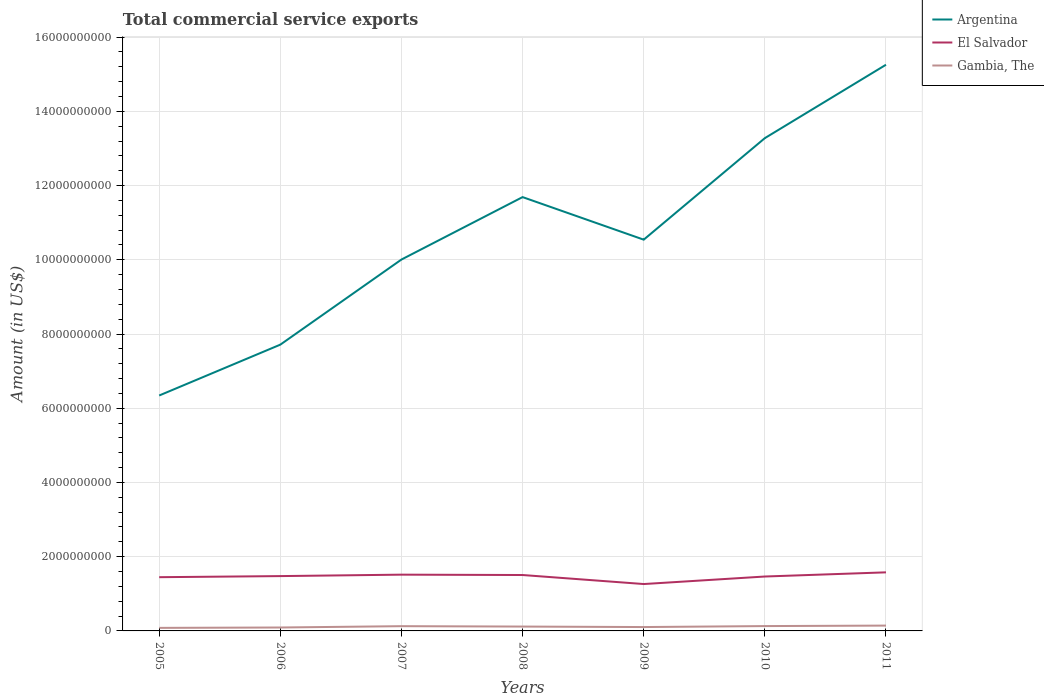Is the number of lines equal to the number of legend labels?
Provide a succinct answer. Yes. Across all years, what is the maximum total commercial service exports in Gambia, The?
Your response must be concise. 8.22e+07. In which year was the total commercial service exports in Argentina maximum?
Offer a very short reply. 2005. What is the total total commercial service exports in El Salvador in the graph?
Your answer should be very brief. 9.69e+06. What is the difference between the highest and the second highest total commercial service exports in Argentina?
Ensure brevity in your answer.  8.91e+09. What is the difference between the highest and the lowest total commercial service exports in El Salvador?
Keep it short and to the point. 5. How many lines are there?
Make the answer very short. 3. What is the difference between two consecutive major ticks on the Y-axis?
Your response must be concise. 2.00e+09. Are the values on the major ticks of Y-axis written in scientific E-notation?
Your answer should be very brief. No. Does the graph contain any zero values?
Ensure brevity in your answer.  No. Does the graph contain grids?
Provide a succinct answer. Yes. Where does the legend appear in the graph?
Your response must be concise. Top right. How many legend labels are there?
Your answer should be very brief. 3. How are the legend labels stacked?
Keep it short and to the point. Vertical. What is the title of the graph?
Provide a short and direct response. Total commercial service exports. What is the label or title of the Y-axis?
Your answer should be very brief. Amount (in US$). What is the Amount (in US$) of Argentina in 2005?
Provide a short and direct response. 6.34e+09. What is the Amount (in US$) of El Salvador in 2005?
Keep it short and to the point. 1.45e+09. What is the Amount (in US$) of Gambia, The in 2005?
Provide a succinct answer. 8.22e+07. What is the Amount (in US$) of Argentina in 2006?
Your answer should be very brief. 7.71e+09. What is the Amount (in US$) in El Salvador in 2006?
Your answer should be very brief. 1.48e+09. What is the Amount (in US$) in Gambia, The in 2006?
Give a very brief answer. 9.21e+07. What is the Amount (in US$) of Argentina in 2007?
Keep it short and to the point. 1.00e+1. What is the Amount (in US$) of El Salvador in 2007?
Your answer should be compact. 1.52e+09. What is the Amount (in US$) of Gambia, The in 2007?
Ensure brevity in your answer.  1.28e+08. What is the Amount (in US$) in Argentina in 2008?
Provide a succinct answer. 1.17e+1. What is the Amount (in US$) of El Salvador in 2008?
Ensure brevity in your answer.  1.51e+09. What is the Amount (in US$) of Gambia, The in 2008?
Your answer should be compact. 1.18e+08. What is the Amount (in US$) of Argentina in 2009?
Ensure brevity in your answer.  1.05e+1. What is the Amount (in US$) in El Salvador in 2009?
Ensure brevity in your answer.  1.26e+09. What is the Amount (in US$) of Gambia, The in 2009?
Your answer should be very brief. 1.04e+08. What is the Amount (in US$) in Argentina in 2010?
Your answer should be compact. 1.33e+1. What is the Amount (in US$) of El Salvador in 2010?
Your answer should be very brief. 1.47e+09. What is the Amount (in US$) in Gambia, The in 2010?
Your answer should be very brief. 1.31e+08. What is the Amount (in US$) of Argentina in 2011?
Give a very brief answer. 1.53e+1. What is the Amount (in US$) of El Salvador in 2011?
Give a very brief answer. 1.58e+09. What is the Amount (in US$) of Gambia, The in 2011?
Give a very brief answer. 1.44e+08. Across all years, what is the maximum Amount (in US$) of Argentina?
Your answer should be compact. 1.53e+1. Across all years, what is the maximum Amount (in US$) of El Salvador?
Make the answer very short. 1.58e+09. Across all years, what is the maximum Amount (in US$) in Gambia, The?
Your answer should be compact. 1.44e+08. Across all years, what is the minimum Amount (in US$) of Argentina?
Offer a very short reply. 6.34e+09. Across all years, what is the minimum Amount (in US$) of El Salvador?
Keep it short and to the point. 1.26e+09. Across all years, what is the minimum Amount (in US$) of Gambia, The?
Offer a very short reply. 8.22e+07. What is the total Amount (in US$) of Argentina in the graph?
Your response must be concise. 7.48e+1. What is the total Amount (in US$) of El Salvador in the graph?
Ensure brevity in your answer.  1.03e+1. What is the total Amount (in US$) in Gambia, The in the graph?
Your response must be concise. 7.98e+08. What is the difference between the Amount (in US$) in Argentina in 2005 and that in 2006?
Keep it short and to the point. -1.37e+09. What is the difference between the Amount (in US$) of El Salvador in 2005 and that in 2006?
Offer a terse response. -2.94e+07. What is the difference between the Amount (in US$) in Gambia, The in 2005 and that in 2006?
Make the answer very short. -9.87e+06. What is the difference between the Amount (in US$) of Argentina in 2005 and that in 2007?
Your answer should be very brief. -3.66e+09. What is the difference between the Amount (in US$) in El Salvador in 2005 and that in 2007?
Your answer should be very brief. -6.83e+07. What is the difference between the Amount (in US$) in Gambia, The in 2005 and that in 2007?
Give a very brief answer. -4.57e+07. What is the difference between the Amount (in US$) in Argentina in 2005 and that in 2008?
Your answer should be compact. -5.35e+09. What is the difference between the Amount (in US$) in El Salvador in 2005 and that in 2008?
Your response must be concise. -5.86e+07. What is the difference between the Amount (in US$) in Gambia, The in 2005 and that in 2008?
Offer a terse response. -3.54e+07. What is the difference between the Amount (in US$) of Argentina in 2005 and that in 2009?
Keep it short and to the point. -4.20e+09. What is the difference between the Amount (in US$) of El Salvador in 2005 and that in 2009?
Provide a short and direct response. 1.85e+08. What is the difference between the Amount (in US$) of Gambia, The in 2005 and that in 2009?
Your answer should be compact. -2.20e+07. What is the difference between the Amount (in US$) in Argentina in 2005 and that in 2010?
Your answer should be very brief. -6.93e+09. What is the difference between the Amount (in US$) of El Salvador in 2005 and that in 2010?
Provide a short and direct response. -1.80e+07. What is the difference between the Amount (in US$) in Gambia, The in 2005 and that in 2010?
Your answer should be compact. -4.84e+07. What is the difference between the Amount (in US$) of Argentina in 2005 and that in 2011?
Provide a short and direct response. -8.91e+09. What is the difference between the Amount (in US$) of El Salvador in 2005 and that in 2011?
Your answer should be very brief. -1.31e+08. What is the difference between the Amount (in US$) of Gambia, The in 2005 and that in 2011?
Keep it short and to the point. -6.15e+07. What is the difference between the Amount (in US$) in Argentina in 2006 and that in 2007?
Keep it short and to the point. -2.29e+09. What is the difference between the Amount (in US$) in El Salvador in 2006 and that in 2007?
Your answer should be very brief. -3.89e+07. What is the difference between the Amount (in US$) in Gambia, The in 2006 and that in 2007?
Ensure brevity in your answer.  -3.59e+07. What is the difference between the Amount (in US$) in Argentina in 2006 and that in 2008?
Provide a short and direct response. -3.98e+09. What is the difference between the Amount (in US$) in El Salvador in 2006 and that in 2008?
Your response must be concise. -2.92e+07. What is the difference between the Amount (in US$) in Gambia, The in 2006 and that in 2008?
Your answer should be compact. -2.55e+07. What is the difference between the Amount (in US$) of Argentina in 2006 and that in 2009?
Offer a terse response. -2.83e+09. What is the difference between the Amount (in US$) of El Salvador in 2006 and that in 2009?
Give a very brief answer. 2.14e+08. What is the difference between the Amount (in US$) of Gambia, The in 2006 and that in 2009?
Provide a short and direct response. -1.21e+07. What is the difference between the Amount (in US$) of Argentina in 2006 and that in 2010?
Make the answer very short. -5.56e+09. What is the difference between the Amount (in US$) in El Salvador in 2006 and that in 2010?
Provide a short and direct response. 1.14e+07. What is the difference between the Amount (in US$) of Gambia, The in 2006 and that in 2010?
Provide a succinct answer. -3.86e+07. What is the difference between the Amount (in US$) of Argentina in 2006 and that in 2011?
Your response must be concise. -7.54e+09. What is the difference between the Amount (in US$) in El Salvador in 2006 and that in 2011?
Provide a succinct answer. -1.01e+08. What is the difference between the Amount (in US$) in Gambia, The in 2006 and that in 2011?
Offer a very short reply. -5.16e+07. What is the difference between the Amount (in US$) in Argentina in 2007 and that in 2008?
Your answer should be compact. -1.68e+09. What is the difference between the Amount (in US$) in El Salvador in 2007 and that in 2008?
Provide a short and direct response. 9.69e+06. What is the difference between the Amount (in US$) in Gambia, The in 2007 and that in 2008?
Offer a very short reply. 1.04e+07. What is the difference between the Amount (in US$) in Argentina in 2007 and that in 2009?
Your response must be concise. -5.35e+08. What is the difference between the Amount (in US$) of El Salvador in 2007 and that in 2009?
Offer a terse response. 2.53e+08. What is the difference between the Amount (in US$) in Gambia, The in 2007 and that in 2009?
Make the answer very short. 2.38e+07. What is the difference between the Amount (in US$) in Argentina in 2007 and that in 2010?
Give a very brief answer. -3.27e+09. What is the difference between the Amount (in US$) in El Salvador in 2007 and that in 2010?
Give a very brief answer. 5.03e+07. What is the difference between the Amount (in US$) in Gambia, The in 2007 and that in 2010?
Your answer should be very brief. -2.70e+06. What is the difference between the Amount (in US$) in Argentina in 2007 and that in 2011?
Your answer should be very brief. -5.25e+09. What is the difference between the Amount (in US$) of El Salvador in 2007 and that in 2011?
Ensure brevity in your answer.  -6.23e+07. What is the difference between the Amount (in US$) of Gambia, The in 2007 and that in 2011?
Provide a succinct answer. -1.58e+07. What is the difference between the Amount (in US$) of Argentina in 2008 and that in 2009?
Your answer should be compact. 1.15e+09. What is the difference between the Amount (in US$) of El Salvador in 2008 and that in 2009?
Offer a terse response. 2.43e+08. What is the difference between the Amount (in US$) of Gambia, The in 2008 and that in 2009?
Your response must be concise. 1.34e+07. What is the difference between the Amount (in US$) in Argentina in 2008 and that in 2010?
Offer a terse response. -1.59e+09. What is the difference between the Amount (in US$) of El Salvador in 2008 and that in 2010?
Keep it short and to the point. 4.06e+07. What is the difference between the Amount (in US$) of Gambia, The in 2008 and that in 2010?
Keep it short and to the point. -1.31e+07. What is the difference between the Amount (in US$) in Argentina in 2008 and that in 2011?
Your response must be concise. -3.57e+09. What is the difference between the Amount (in US$) of El Salvador in 2008 and that in 2011?
Offer a terse response. -7.20e+07. What is the difference between the Amount (in US$) of Gambia, The in 2008 and that in 2011?
Make the answer very short. -2.62e+07. What is the difference between the Amount (in US$) in Argentina in 2009 and that in 2010?
Offer a very short reply. -2.74e+09. What is the difference between the Amount (in US$) in El Salvador in 2009 and that in 2010?
Provide a succinct answer. -2.03e+08. What is the difference between the Amount (in US$) in Gambia, The in 2009 and that in 2010?
Provide a short and direct response. -2.65e+07. What is the difference between the Amount (in US$) in Argentina in 2009 and that in 2011?
Provide a short and direct response. -4.71e+09. What is the difference between the Amount (in US$) in El Salvador in 2009 and that in 2011?
Your answer should be very brief. -3.15e+08. What is the difference between the Amount (in US$) of Gambia, The in 2009 and that in 2011?
Keep it short and to the point. -3.95e+07. What is the difference between the Amount (in US$) in Argentina in 2010 and that in 2011?
Give a very brief answer. -1.98e+09. What is the difference between the Amount (in US$) of El Salvador in 2010 and that in 2011?
Offer a very short reply. -1.13e+08. What is the difference between the Amount (in US$) of Gambia, The in 2010 and that in 2011?
Provide a succinct answer. -1.31e+07. What is the difference between the Amount (in US$) in Argentina in 2005 and the Amount (in US$) in El Salvador in 2006?
Make the answer very short. 4.87e+09. What is the difference between the Amount (in US$) in Argentina in 2005 and the Amount (in US$) in Gambia, The in 2006?
Offer a terse response. 6.25e+09. What is the difference between the Amount (in US$) in El Salvador in 2005 and the Amount (in US$) in Gambia, The in 2006?
Provide a short and direct response. 1.36e+09. What is the difference between the Amount (in US$) of Argentina in 2005 and the Amount (in US$) of El Salvador in 2007?
Ensure brevity in your answer.  4.83e+09. What is the difference between the Amount (in US$) of Argentina in 2005 and the Amount (in US$) of Gambia, The in 2007?
Offer a terse response. 6.21e+09. What is the difference between the Amount (in US$) of El Salvador in 2005 and the Amount (in US$) of Gambia, The in 2007?
Make the answer very short. 1.32e+09. What is the difference between the Amount (in US$) of Argentina in 2005 and the Amount (in US$) of El Salvador in 2008?
Offer a very short reply. 4.84e+09. What is the difference between the Amount (in US$) of Argentina in 2005 and the Amount (in US$) of Gambia, The in 2008?
Your answer should be very brief. 6.23e+09. What is the difference between the Amount (in US$) of El Salvador in 2005 and the Amount (in US$) of Gambia, The in 2008?
Your answer should be very brief. 1.33e+09. What is the difference between the Amount (in US$) in Argentina in 2005 and the Amount (in US$) in El Salvador in 2009?
Give a very brief answer. 5.08e+09. What is the difference between the Amount (in US$) in Argentina in 2005 and the Amount (in US$) in Gambia, The in 2009?
Give a very brief answer. 6.24e+09. What is the difference between the Amount (in US$) in El Salvador in 2005 and the Amount (in US$) in Gambia, The in 2009?
Offer a terse response. 1.34e+09. What is the difference between the Amount (in US$) of Argentina in 2005 and the Amount (in US$) of El Salvador in 2010?
Keep it short and to the point. 4.88e+09. What is the difference between the Amount (in US$) in Argentina in 2005 and the Amount (in US$) in Gambia, The in 2010?
Give a very brief answer. 6.21e+09. What is the difference between the Amount (in US$) of El Salvador in 2005 and the Amount (in US$) of Gambia, The in 2010?
Your response must be concise. 1.32e+09. What is the difference between the Amount (in US$) of Argentina in 2005 and the Amount (in US$) of El Salvador in 2011?
Provide a succinct answer. 4.76e+09. What is the difference between the Amount (in US$) of Argentina in 2005 and the Amount (in US$) of Gambia, The in 2011?
Make the answer very short. 6.20e+09. What is the difference between the Amount (in US$) in El Salvador in 2005 and the Amount (in US$) in Gambia, The in 2011?
Your answer should be compact. 1.30e+09. What is the difference between the Amount (in US$) in Argentina in 2006 and the Amount (in US$) in El Salvador in 2007?
Offer a very short reply. 6.20e+09. What is the difference between the Amount (in US$) of Argentina in 2006 and the Amount (in US$) of Gambia, The in 2007?
Your answer should be compact. 7.59e+09. What is the difference between the Amount (in US$) of El Salvador in 2006 and the Amount (in US$) of Gambia, The in 2007?
Your answer should be very brief. 1.35e+09. What is the difference between the Amount (in US$) of Argentina in 2006 and the Amount (in US$) of El Salvador in 2008?
Provide a short and direct response. 6.21e+09. What is the difference between the Amount (in US$) in Argentina in 2006 and the Amount (in US$) in Gambia, The in 2008?
Provide a succinct answer. 7.60e+09. What is the difference between the Amount (in US$) in El Salvador in 2006 and the Amount (in US$) in Gambia, The in 2008?
Ensure brevity in your answer.  1.36e+09. What is the difference between the Amount (in US$) in Argentina in 2006 and the Amount (in US$) in El Salvador in 2009?
Your answer should be compact. 6.45e+09. What is the difference between the Amount (in US$) of Argentina in 2006 and the Amount (in US$) of Gambia, The in 2009?
Your response must be concise. 7.61e+09. What is the difference between the Amount (in US$) in El Salvador in 2006 and the Amount (in US$) in Gambia, The in 2009?
Keep it short and to the point. 1.37e+09. What is the difference between the Amount (in US$) of Argentina in 2006 and the Amount (in US$) of El Salvador in 2010?
Keep it short and to the point. 6.25e+09. What is the difference between the Amount (in US$) of Argentina in 2006 and the Amount (in US$) of Gambia, The in 2010?
Offer a terse response. 7.58e+09. What is the difference between the Amount (in US$) in El Salvador in 2006 and the Amount (in US$) in Gambia, The in 2010?
Provide a succinct answer. 1.35e+09. What is the difference between the Amount (in US$) in Argentina in 2006 and the Amount (in US$) in El Salvador in 2011?
Your answer should be compact. 6.14e+09. What is the difference between the Amount (in US$) of Argentina in 2006 and the Amount (in US$) of Gambia, The in 2011?
Your answer should be very brief. 7.57e+09. What is the difference between the Amount (in US$) of El Salvador in 2006 and the Amount (in US$) of Gambia, The in 2011?
Your response must be concise. 1.33e+09. What is the difference between the Amount (in US$) of Argentina in 2007 and the Amount (in US$) of El Salvador in 2008?
Provide a succinct answer. 8.50e+09. What is the difference between the Amount (in US$) of Argentina in 2007 and the Amount (in US$) of Gambia, The in 2008?
Offer a very short reply. 9.89e+09. What is the difference between the Amount (in US$) of El Salvador in 2007 and the Amount (in US$) of Gambia, The in 2008?
Your response must be concise. 1.40e+09. What is the difference between the Amount (in US$) in Argentina in 2007 and the Amount (in US$) in El Salvador in 2009?
Your response must be concise. 8.74e+09. What is the difference between the Amount (in US$) of Argentina in 2007 and the Amount (in US$) of Gambia, The in 2009?
Ensure brevity in your answer.  9.90e+09. What is the difference between the Amount (in US$) in El Salvador in 2007 and the Amount (in US$) in Gambia, The in 2009?
Keep it short and to the point. 1.41e+09. What is the difference between the Amount (in US$) of Argentina in 2007 and the Amount (in US$) of El Salvador in 2010?
Provide a short and direct response. 8.54e+09. What is the difference between the Amount (in US$) of Argentina in 2007 and the Amount (in US$) of Gambia, The in 2010?
Make the answer very short. 9.88e+09. What is the difference between the Amount (in US$) in El Salvador in 2007 and the Amount (in US$) in Gambia, The in 2010?
Your answer should be very brief. 1.39e+09. What is the difference between the Amount (in US$) of Argentina in 2007 and the Amount (in US$) of El Salvador in 2011?
Offer a very short reply. 8.43e+09. What is the difference between the Amount (in US$) of Argentina in 2007 and the Amount (in US$) of Gambia, The in 2011?
Your response must be concise. 9.86e+09. What is the difference between the Amount (in US$) of El Salvador in 2007 and the Amount (in US$) of Gambia, The in 2011?
Make the answer very short. 1.37e+09. What is the difference between the Amount (in US$) in Argentina in 2008 and the Amount (in US$) in El Salvador in 2009?
Make the answer very short. 1.04e+1. What is the difference between the Amount (in US$) in Argentina in 2008 and the Amount (in US$) in Gambia, The in 2009?
Your answer should be very brief. 1.16e+1. What is the difference between the Amount (in US$) in El Salvador in 2008 and the Amount (in US$) in Gambia, The in 2009?
Your answer should be compact. 1.40e+09. What is the difference between the Amount (in US$) of Argentina in 2008 and the Amount (in US$) of El Salvador in 2010?
Keep it short and to the point. 1.02e+1. What is the difference between the Amount (in US$) in Argentina in 2008 and the Amount (in US$) in Gambia, The in 2010?
Keep it short and to the point. 1.16e+1. What is the difference between the Amount (in US$) of El Salvador in 2008 and the Amount (in US$) of Gambia, The in 2010?
Offer a very short reply. 1.38e+09. What is the difference between the Amount (in US$) of Argentina in 2008 and the Amount (in US$) of El Salvador in 2011?
Give a very brief answer. 1.01e+1. What is the difference between the Amount (in US$) in Argentina in 2008 and the Amount (in US$) in Gambia, The in 2011?
Your answer should be very brief. 1.15e+1. What is the difference between the Amount (in US$) of El Salvador in 2008 and the Amount (in US$) of Gambia, The in 2011?
Make the answer very short. 1.36e+09. What is the difference between the Amount (in US$) of Argentina in 2009 and the Amount (in US$) of El Salvador in 2010?
Offer a terse response. 9.08e+09. What is the difference between the Amount (in US$) of Argentina in 2009 and the Amount (in US$) of Gambia, The in 2010?
Make the answer very short. 1.04e+1. What is the difference between the Amount (in US$) in El Salvador in 2009 and the Amount (in US$) in Gambia, The in 2010?
Provide a succinct answer. 1.13e+09. What is the difference between the Amount (in US$) in Argentina in 2009 and the Amount (in US$) in El Salvador in 2011?
Keep it short and to the point. 8.96e+09. What is the difference between the Amount (in US$) of Argentina in 2009 and the Amount (in US$) of Gambia, The in 2011?
Offer a terse response. 1.04e+1. What is the difference between the Amount (in US$) in El Salvador in 2009 and the Amount (in US$) in Gambia, The in 2011?
Offer a terse response. 1.12e+09. What is the difference between the Amount (in US$) of Argentina in 2010 and the Amount (in US$) of El Salvador in 2011?
Offer a terse response. 1.17e+1. What is the difference between the Amount (in US$) of Argentina in 2010 and the Amount (in US$) of Gambia, The in 2011?
Give a very brief answer. 1.31e+1. What is the difference between the Amount (in US$) of El Salvador in 2010 and the Amount (in US$) of Gambia, The in 2011?
Your response must be concise. 1.32e+09. What is the average Amount (in US$) of Argentina per year?
Keep it short and to the point. 1.07e+1. What is the average Amount (in US$) in El Salvador per year?
Your response must be concise. 1.46e+09. What is the average Amount (in US$) of Gambia, The per year?
Ensure brevity in your answer.  1.14e+08. In the year 2005, what is the difference between the Amount (in US$) in Argentina and Amount (in US$) in El Salvador?
Offer a terse response. 4.90e+09. In the year 2005, what is the difference between the Amount (in US$) of Argentina and Amount (in US$) of Gambia, The?
Your answer should be compact. 6.26e+09. In the year 2005, what is the difference between the Amount (in US$) in El Salvador and Amount (in US$) in Gambia, The?
Provide a short and direct response. 1.37e+09. In the year 2006, what is the difference between the Amount (in US$) in Argentina and Amount (in US$) in El Salvador?
Your answer should be compact. 6.24e+09. In the year 2006, what is the difference between the Amount (in US$) in Argentina and Amount (in US$) in Gambia, The?
Offer a terse response. 7.62e+09. In the year 2006, what is the difference between the Amount (in US$) in El Salvador and Amount (in US$) in Gambia, The?
Give a very brief answer. 1.39e+09. In the year 2007, what is the difference between the Amount (in US$) in Argentina and Amount (in US$) in El Salvador?
Make the answer very short. 8.49e+09. In the year 2007, what is the difference between the Amount (in US$) in Argentina and Amount (in US$) in Gambia, The?
Give a very brief answer. 9.88e+09. In the year 2007, what is the difference between the Amount (in US$) in El Salvador and Amount (in US$) in Gambia, The?
Your answer should be very brief. 1.39e+09. In the year 2008, what is the difference between the Amount (in US$) in Argentina and Amount (in US$) in El Salvador?
Keep it short and to the point. 1.02e+1. In the year 2008, what is the difference between the Amount (in US$) of Argentina and Amount (in US$) of Gambia, The?
Your answer should be very brief. 1.16e+1. In the year 2008, what is the difference between the Amount (in US$) in El Salvador and Amount (in US$) in Gambia, The?
Your answer should be very brief. 1.39e+09. In the year 2009, what is the difference between the Amount (in US$) of Argentina and Amount (in US$) of El Salvador?
Your answer should be very brief. 9.28e+09. In the year 2009, what is the difference between the Amount (in US$) in Argentina and Amount (in US$) in Gambia, The?
Provide a succinct answer. 1.04e+1. In the year 2009, what is the difference between the Amount (in US$) in El Salvador and Amount (in US$) in Gambia, The?
Your answer should be very brief. 1.16e+09. In the year 2010, what is the difference between the Amount (in US$) in Argentina and Amount (in US$) in El Salvador?
Your response must be concise. 1.18e+1. In the year 2010, what is the difference between the Amount (in US$) in Argentina and Amount (in US$) in Gambia, The?
Your response must be concise. 1.31e+1. In the year 2010, what is the difference between the Amount (in US$) of El Salvador and Amount (in US$) of Gambia, The?
Your response must be concise. 1.34e+09. In the year 2011, what is the difference between the Amount (in US$) in Argentina and Amount (in US$) in El Salvador?
Ensure brevity in your answer.  1.37e+1. In the year 2011, what is the difference between the Amount (in US$) in Argentina and Amount (in US$) in Gambia, The?
Your answer should be compact. 1.51e+1. In the year 2011, what is the difference between the Amount (in US$) of El Salvador and Amount (in US$) of Gambia, The?
Your answer should be very brief. 1.43e+09. What is the ratio of the Amount (in US$) in Argentina in 2005 to that in 2006?
Keep it short and to the point. 0.82. What is the ratio of the Amount (in US$) in El Salvador in 2005 to that in 2006?
Offer a terse response. 0.98. What is the ratio of the Amount (in US$) of Gambia, The in 2005 to that in 2006?
Provide a short and direct response. 0.89. What is the ratio of the Amount (in US$) in Argentina in 2005 to that in 2007?
Offer a very short reply. 0.63. What is the ratio of the Amount (in US$) in El Salvador in 2005 to that in 2007?
Provide a succinct answer. 0.95. What is the ratio of the Amount (in US$) of Gambia, The in 2005 to that in 2007?
Make the answer very short. 0.64. What is the ratio of the Amount (in US$) of Argentina in 2005 to that in 2008?
Offer a very short reply. 0.54. What is the ratio of the Amount (in US$) of El Salvador in 2005 to that in 2008?
Offer a very short reply. 0.96. What is the ratio of the Amount (in US$) in Gambia, The in 2005 to that in 2008?
Your response must be concise. 0.7. What is the ratio of the Amount (in US$) in Argentina in 2005 to that in 2009?
Provide a short and direct response. 0.6. What is the ratio of the Amount (in US$) of El Salvador in 2005 to that in 2009?
Your response must be concise. 1.15. What is the ratio of the Amount (in US$) of Gambia, The in 2005 to that in 2009?
Offer a very short reply. 0.79. What is the ratio of the Amount (in US$) in Argentina in 2005 to that in 2010?
Your response must be concise. 0.48. What is the ratio of the Amount (in US$) of Gambia, The in 2005 to that in 2010?
Your answer should be compact. 0.63. What is the ratio of the Amount (in US$) in Argentina in 2005 to that in 2011?
Keep it short and to the point. 0.42. What is the ratio of the Amount (in US$) in El Salvador in 2005 to that in 2011?
Ensure brevity in your answer.  0.92. What is the ratio of the Amount (in US$) in Gambia, The in 2005 to that in 2011?
Offer a very short reply. 0.57. What is the ratio of the Amount (in US$) in Argentina in 2006 to that in 2007?
Your response must be concise. 0.77. What is the ratio of the Amount (in US$) in El Salvador in 2006 to that in 2007?
Give a very brief answer. 0.97. What is the ratio of the Amount (in US$) in Gambia, The in 2006 to that in 2007?
Your answer should be very brief. 0.72. What is the ratio of the Amount (in US$) of Argentina in 2006 to that in 2008?
Keep it short and to the point. 0.66. What is the ratio of the Amount (in US$) of El Salvador in 2006 to that in 2008?
Your answer should be very brief. 0.98. What is the ratio of the Amount (in US$) of Gambia, The in 2006 to that in 2008?
Provide a succinct answer. 0.78. What is the ratio of the Amount (in US$) of Argentina in 2006 to that in 2009?
Give a very brief answer. 0.73. What is the ratio of the Amount (in US$) in El Salvador in 2006 to that in 2009?
Provide a short and direct response. 1.17. What is the ratio of the Amount (in US$) in Gambia, The in 2006 to that in 2009?
Your answer should be compact. 0.88. What is the ratio of the Amount (in US$) of Argentina in 2006 to that in 2010?
Make the answer very short. 0.58. What is the ratio of the Amount (in US$) in Gambia, The in 2006 to that in 2010?
Offer a terse response. 0.7. What is the ratio of the Amount (in US$) of Argentina in 2006 to that in 2011?
Keep it short and to the point. 0.51. What is the ratio of the Amount (in US$) of El Salvador in 2006 to that in 2011?
Provide a short and direct response. 0.94. What is the ratio of the Amount (in US$) in Gambia, The in 2006 to that in 2011?
Keep it short and to the point. 0.64. What is the ratio of the Amount (in US$) in Argentina in 2007 to that in 2008?
Provide a short and direct response. 0.86. What is the ratio of the Amount (in US$) in El Salvador in 2007 to that in 2008?
Your answer should be very brief. 1.01. What is the ratio of the Amount (in US$) of Gambia, The in 2007 to that in 2008?
Provide a succinct answer. 1.09. What is the ratio of the Amount (in US$) of Argentina in 2007 to that in 2009?
Make the answer very short. 0.95. What is the ratio of the Amount (in US$) of El Salvador in 2007 to that in 2009?
Ensure brevity in your answer.  1.2. What is the ratio of the Amount (in US$) of Gambia, The in 2007 to that in 2009?
Provide a succinct answer. 1.23. What is the ratio of the Amount (in US$) of Argentina in 2007 to that in 2010?
Keep it short and to the point. 0.75. What is the ratio of the Amount (in US$) in El Salvador in 2007 to that in 2010?
Make the answer very short. 1.03. What is the ratio of the Amount (in US$) of Gambia, The in 2007 to that in 2010?
Keep it short and to the point. 0.98. What is the ratio of the Amount (in US$) in Argentina in 2007 to that in 2011?
Your answer should be compact. 0.66. What is the ratio of the Amount (in US$) in El Salvador in 2007 to that in 2011?
Provide a short and direct response. 0.96. What is the ratio of the Amount (in US$) of Gambia, The in 2007 to that in 2011?
Your answer should be very brief. 0.89. What is the ratio of the Amount (in US$) of Argentina in 2008 to that in 2009?
Make the answer very short. 1.11. What is the ratio of the Amount (in US$) of El Salvador in 2008 to that in 2009?
Your answer should be compact. 1.19. What is the ratio of the Amount (in US$) of Gambia, The in 2008 to that in 2009?
Keep it short and to the point. 1.13. What is the ratio of the Amount (in US$) in Argentina in 2008 to that in 2010?
Your response must be concise. 0.88. What is the ratio of the Amount (in US$) in El Salvador in 2008 to that in 2010?
Your response must be concise. 1.03. What is the ratio of the Amount (in US$) of Gambia, The in 2008 to that in 2010?
Make the answer very short. 0.9. What is the ratio of the Amount (in US$) of Argentina in 2008 to that in 2011?
Provide a short and direct response. 0.77. What is the ratio of the Amount (in US$) in El Salvador in 2008 to that in 2011?
Provide a short and direct response. 0.95. What is the ratio of the Amount (in US$) of Gambia, The in 2008 to that in 2011?
Provide a short and direct response. 0.82. What is the ratio of the Amount (in US$) in Argentina in 2009 to that in 2010?
Offer a terse response. 0.79. What is the ratio of the Amount (in US$) in El Salvador in 2009 to that in 2010?
Keep it short and to the point. 0.86. What is the ratio of the Amount (in US$) of Gambia, The in 2009 to that in 2010?
Make the answer very short. 0.8. What is the ratio of the Amount (in US$) of Argentina in 2009 to that in 2011?
Your answer should be compact. 0.69. What is the ratio of the Amount (in US$) in El Salvador in 2009 to that in 2011?
Make the answer very short. 0.8. What is the ratio of the Amount (in US$) in Gambia, The in 2009 to that in 2011?
Your answer should be very brief. 0.72. What is the ratio of the Amount (in US$) in Argentina in 2010 to that in 2011?
Ensure brevity in your answer.  0.87. What is the ratio of the Amount (in US$) of El Salvador in 2010 to that in 2011?
Make the answer very short. 0.93. What is the ratio of the Amount (in US$) in Gambia, The in 2010 to that in 2011?
Keep it short and to the point. 0.91. What is the difference between the highest and the second highest Amount (in US$) in Argentina?
Your answer should be very brief. 1.98e+09. What is the difference between the highest and the second highest Amount (in US$) of El Salvador?
Your answer should be compact. 6.23e+07. What is the difference between the highest and the second highest Amount (in US$) of Gambia, The?
Offer a very short reply. 1.31e+07. What is the difference between the highest and the lowest Amount (in US$) in Argentina?
Keep it short and to the point. 8.91e+09. What is the difference between the highest and the lowest Amount (in US$) in El Salvador?
Keep it short and to the point. 3.15e+08. What is the difference between the highest and the lowest Amount (in US$) in Gambia, The?
Your answer should be compact. 6.15e+07. 